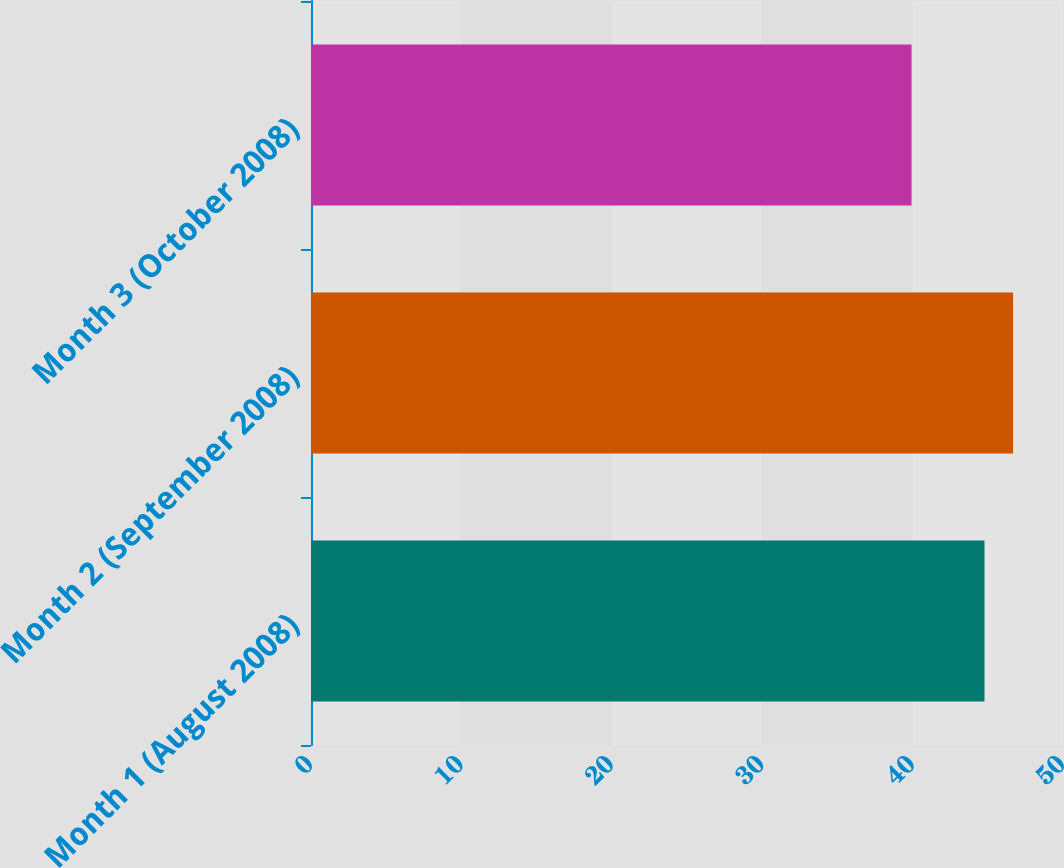<chart> <loc_0><loc_0><loc_500><loc_500><bar_chart><fcel>Month 1 (August 2008)<fcel>Month 2 (September 2008)<fcel>Month 3 (October 2008)<nl><fcel>44.78<fcel>46.68<fcel>39.93<nl></chart> 